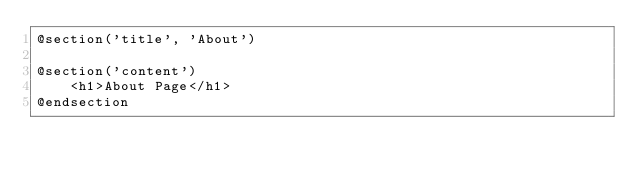Convert code to text. <code><loc_0><loc_0><loc_500><loc_500><_PHP_>@section('title', 'About')
    
@section('content')
    <h1>About Page</h1>
@endsection</code> 